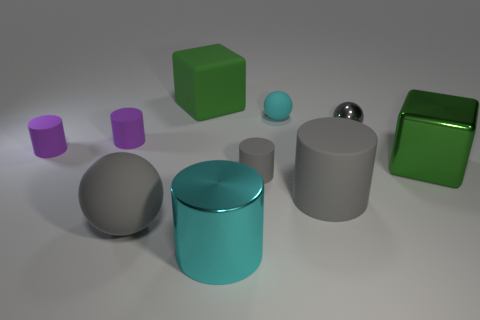Subtract all gray spheres. How many spheres are left? 1 Subtract all gray spheres. How many gray cylinders are left? 2 Subtract 1 balls. How many balls are left? 2 Subtract all cyan balls. How many balls are left? 2 Subtract 0 blue cubes. How many objects are left? 10 Subtract all balls. How many objects are left? 7 Subtract all yellow blocks. Subtract all cyan cylinders. How many blocks are left? 2 Subtract all small gray matte cylinders. Subtract all small metal balls. How many objects are left? 8 Add 2 gray matte objects. How many gray matte objects are left? 5 Add 1 large red blocks. How many large red blocks exist? 1 